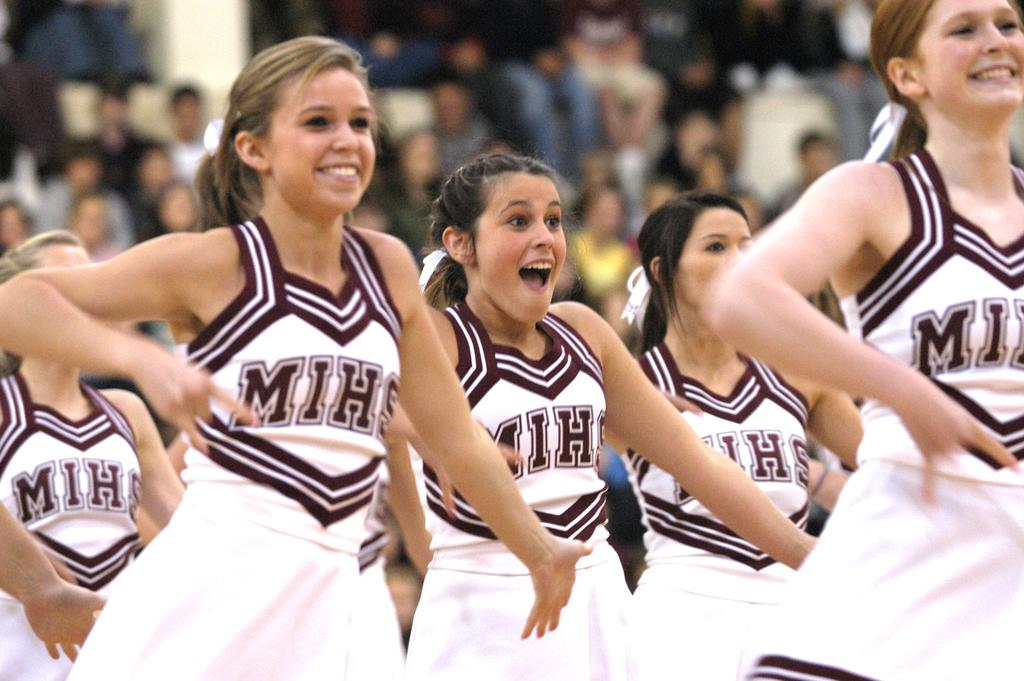<image>
Write a terse but informative summary of the picture. A number of girls in MIHS cheerleading uniforms. 